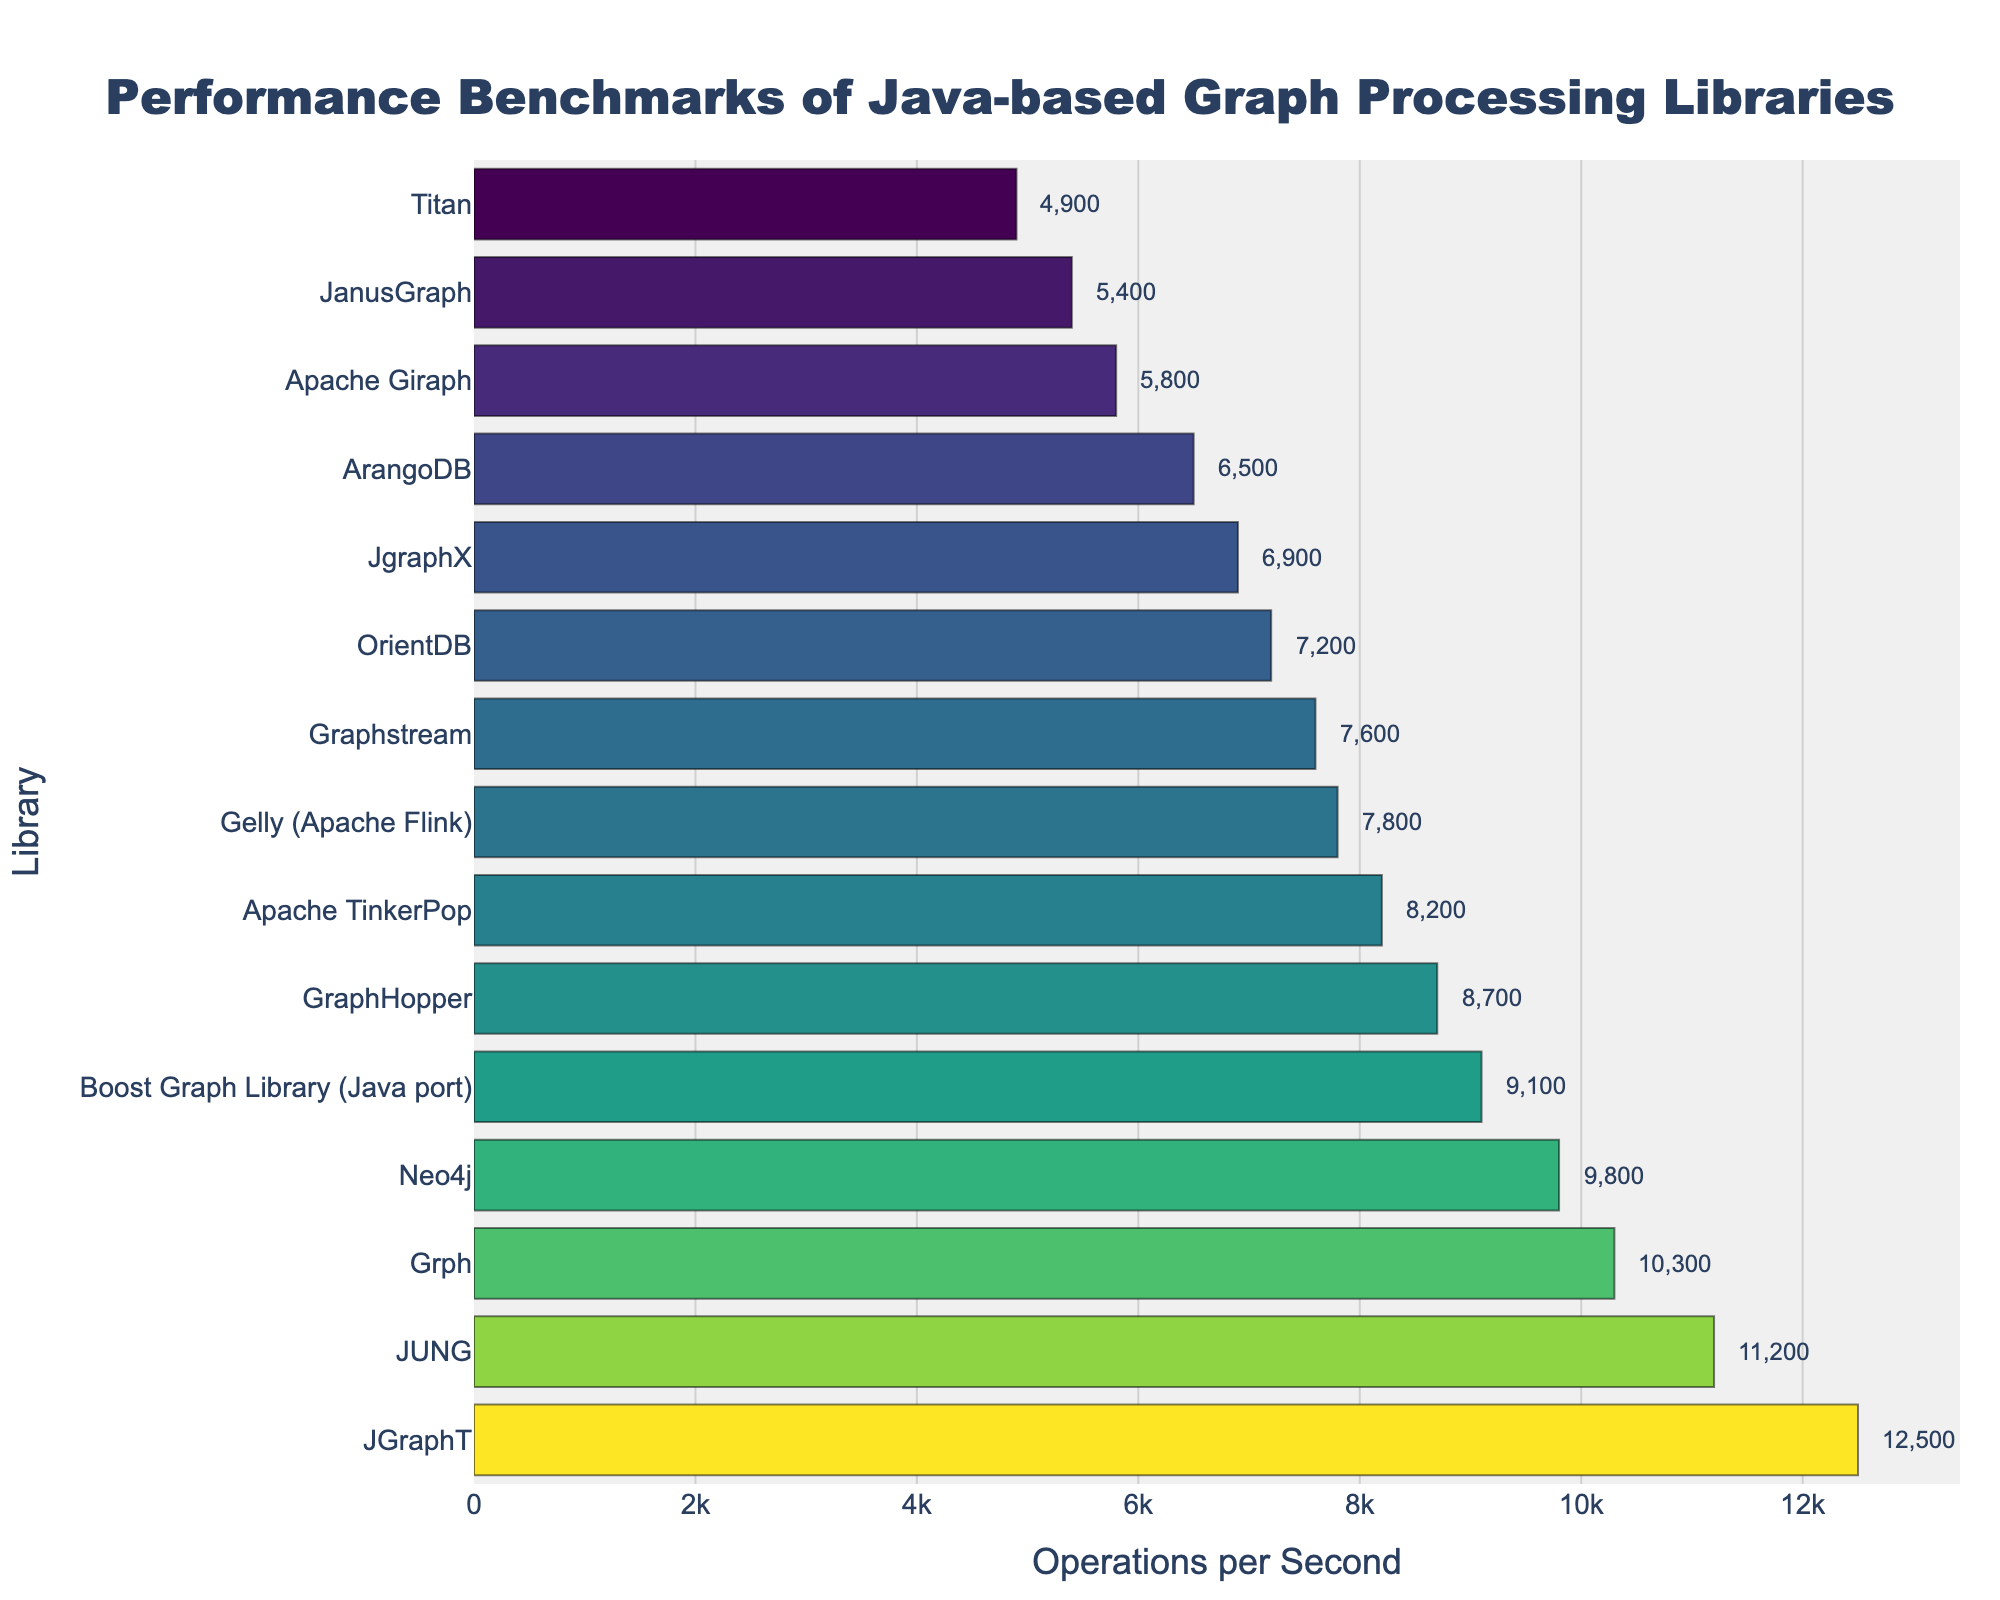Which library has the highest performance in terms of operations per second? By looking at the bar chart, the tallest bar represents the library with the highest performance. The library 'JGraphT' has the tallest bar.
Answer: JGraphT Which library performs better, Apache TinkerPop or Graphstream? By comparing the heights of the bars for Apache TinkerPop and Graphstream, Apache TinkerPop has a taller bar, indicating better performance.
Answer: Apache TinkerPop What is the performance difference between JUNG and Grph? JUNG has 11,200 operations per second and Grph has 10,300 operations per second. The difference is calculated by subtracting the two values: 11,200 - 10,300 = 900.
Answer: 900 Which libraries have performance lower than 8,000 operations per second? By examining the bars shorter than the 8,000 mark on the x-axis, we identify Graphstream, JgraphX, Apache Giraph, OrientDB, ArangoDB, JanusGraph, and Titan.
Answer: Graphstream, JgraphX, Apache Giraph, OrientDB, ArangoDB, JanusGraph, Titan Out of the top 5 libraries, which one has the lowest performance? The top 5 libraries are JGraphT, JUNG, Grph, Neo4j, and Boost Graph Library (Java port). Among these, the Boost Graph Library (Java port) has the lowest number of operations per second with 9,100.
Answer: Boost Graph Library (Java port) What is the cumulative performance (sum of operations per second) of Neo4j, GraphHopper, and OrientDB? The operations per second are 9,800 for Neo4j, 8,700 for GraphHopper, and 7,200 for OrientDB. Adding these together: 9,800 + 8,700 + 7,200 = 25,700.
Answer: 25,700 Which library has the most similar performance to Apache TinkerPop? Apache TinkerPop has 8,200 operations per second. Comparing nearby values, GraphHopper has 8,700 and Gelly (Apache Flink) has 7,800. Gelly (Apache Flink) is closer: (8,200 - 7,800 = 400) vs. (8,700 - 8,200 = 500).
Answer: Gelly (Apache Flink) What is the average performance of the bottom three libraries? The bottom three libraries are Apache Giraph (5,800), JanusGraph (5,400), and Titan (4,900). The average is calculated as: (5,800 + 5,400 + 4,900) / 3 = 5,366.67.
Answer: 5,367 Compare the performance difference between the best and the worst performing libraries. The best-performing library is JGraphT with 12,500 operations per second and the worst-performing library is Titan with 4,900 operations per second. The difference is calculated as: 12,500 - 4,900 = 7,600.
Answer: 7,600 